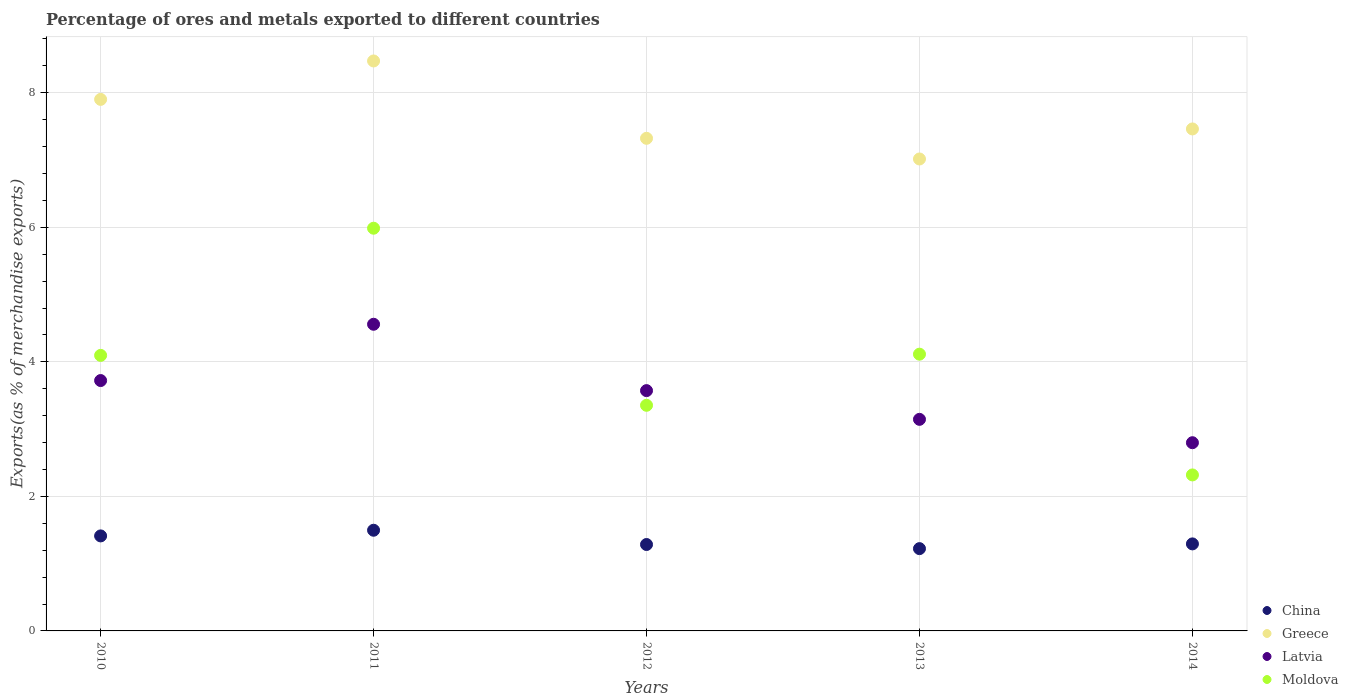Is the number of dotlines equal to the number of legend labels?
Offer a very short reply. Yes. What is the percentage of exports to different countries in Greece in 2014?
Offer a very short reply. 7.46. Across all years, what is the maximum percentage of exports to different countries in Greece?
Give a very brief answer. 8.47. Across all years, what is the minimum percentage of exports to different countries in Greece?
Provide a succinct answer. 7.02. In which year was the percentage of exports to different countries in Moldova maximum?
Offer a very short reply. 2011. In which year was the percentage of exports to different countries in Latvia minimum?
Give a very brief answer. 2014. What is the total percentage of exports to different countries in Greece in the graph?
Provide a succinct answer. 38.17. What is the difference between the percentage of exports to different countries in Latvia in 2012 and that in 2014?
Your answer should be very brief. 0.77. What is the difference between the percentage of exports to different countries in Greece in 2011 and the percentage of exports to different countries in Latvia in 2013?
Your answer should be very brief. 5.33. What is the average percentage of exports to different countries in Moldova per year?
Make the answer very short. 3.97. In the year 2014, what is the difference between the percentage of exports to different countries in Greece and percentage of exports to different countries in China?
Offer a very short reply. 6.17. In how many years, is the percentage of exports to different countries in Moldova greater than 3.6 %?
Provide a succinct answer. 3. What is the ratio of the percentage of exports to different countries in China in 2012 to that in 2013?
Keep it short and to the point. 1.05. Is the percentage of exports to different countries in Greece in 2010 less than that in 2013?
Provide a succinct answer. No. Is the difference between the percentage of exports to different countries in Greece in 2010 and 2013 greater than the difference between the percentage of exports to different countries in China in 2010 and 2013?
Keep it short and to the point. Yes. What is the difference between the highest and the second highest percentage of exports to different countries in China?
Provide a succinct answer. 0.08. What is the difference between the highest and the lowest percentage of exports to different countries in Greece?
Ensure brevity in your answer.  1.46. Is the sum of the percentage of exports to different countries in Greece in 2012 and 2014 greater than the maximum percentage of exports to different countries in Moldova across all years?
Offer a terse response. Yes. Is it the case that in every year, the sum of the percentage of exports to different countries in Greece and percentage of exports to different countries in Latvia  is greater than the sum of percentage of exports to different countries in China and percentage of exports to different countries in Moldova?
Offer a very short reply. Yes. Does the percentage of exports to different countries in Moldova monotonically increase over the years?
Provide a succinct answer. No. Does the graph contain any zero values?
Give a very brief answer. No. Does the graph contain grids?
Your response must be concise. Yes. How many legend labels are there?
Provide a succinct answer. 4. What is the title of the graph?
Your answer should be very brief. Percentage of ores and metals exported to different countries. Does "South Africa" appear as one of the legend labels in the graph?
Offer a terse response. No. What is the label or title of the Y-axis?
Give a very brief answer. Exports(as % of merchandise exports). What is the Exports(as % of merchandise exports) of China in 2010?
Ensure brevity in your answer.  1.41. What is the Exports(as % of merchandise exports) of Greece in 2010?
Your answer should be very brief. 7.9. What is the Exports(as % of merchandise exports) in Latvia in 2010?
Your answer should be very brief. 3.72. What is the Exports(as % of merchandise exports) of Moldova in 2010?
Give a very brief answer. 4.1. What is the Exports(as % of merchandise exports) of China in 2011?
Your answer should be compact. 1.5. What is the Exports(as % of merchandise exports) in Greece in 2011?
Make the answer very short. 8.47. What is the Exports(as % of merchandise exports) of Latvia in 2011?
Provide a short and direct response. 4.56. What is the Exports(as % of merchandise exports) of Moldova in 2011?
Offer a terse response. 5.99. What is the Exports(as % of merchandise exports) in China in 2012?
Provide a succinct answer. 1.28. What is the Exports(as % of merchandise exports) of Greece in 2012?
Your answer should be very brief. 7.32. What is the Exports(as % of merchandise exports) in Latvia in 2012?
Offer a very short reply. 3.57. What is the Exports(as % of merchandise exports) in Moldova in 2012?
Ensure brevity in your answer.  3.35. What is the Exports(as % of merchandise exports) of China in 2013?
Provide a succinct answer. 1.22. What is the Exports(as % of merchandise exports) of Greece in 2013?
Your answer should be compact. 7.02. What is the Exports(as % of merchandise exports) in Latvia in 2013?
Your answer should be compact. 3.14. What is the Exports(as % of merchandise exports) of Moldova in 2013?
Your answer should be compact. 4.11. What is the Exports(as % of merchandise exports) in China in 2014?
Provide a short and direct response. 1.29. What is the Exports(as % of merchandise exports) in Greece in 2014?
Provide a succinct answer. 7.46. What is the Exports(as % of merchandise exports) of Latvia in 2014?
Keep it short and to the point. 2.8. What is the Exports(as % of merchandise exports) of Moldova in 2014?
Your response must be concise. 2.32. Across all years, what is the maximum Exports(as % of merchandise exports) in China?
Your answer should be very brief. 1.5. Across all years, what is the maximum Exports(as % of merchandise exports) of Greece?
Your response must be concise. 8.47. Across all years, what is the maximum Exports(as % of merchandise exports) in Latvia?
Make the answer very short. 4.56. Across all years, what is the maximum Exports(as % of merchandise exports) in Moldova?
Give a very brief answer. 5.99. Across all years, what is the minimum Exports(as % of merchandise exports) in China?
Make the answer very short. 1.22. Across all years, what is the minimum Exports(as % of merchandise exports) in Greece?
Provide a succinct answer. 7.02. Across all years, what is the minimum Exports(as % of merchandise exports) in Latvia?
Your answer should be compact. 2.8. Across all years, what is the minimum Exports(as % of merchandise exports) of Moldova?
Offer a very short reply. 2.32. What is the total Exports(as % of merchandise exports) in China in the graph?
Keep it short and to the point. 6.71. What is the total Exports(as % of merchandise exports) in Greece in the graph?
Your response must be concise. 38.17. What is the total Exports(as % of merchandise exports) in Latvia in the graph?
Offer a terse response. 17.79. What is the total Exports(as % of merchandise exports) of Moldova in the graph?
Your answer should be compact. 19.87. What is the difference between the Exports(as % of merchandise exports) of China in 2010 and that in 2011?
Offer a very short reply. -0.08. What is the difference between the Exports(as % of merchandise exports) in Greece in 2010 and that in 2011?
Provide a succinct answer. -0.57. What is the difference between the Exports(as % of merchandise exports) of Latvia in 2010 and that in 2011?
Give a very brief answer. -0.84. What is the difference between the Exports(as % of merchandise exports) of Moldova in 2010 and that in 2011?
Your answer should be compact. -1.89. What is the difference between the Exports(as % of merchandise exports) in China in 2010 and that in 2012?
Keep it short and to the point. 0.13. What is the difference between the Exports(as % of merchandise exports) in Greece in 2010 and that in 2012?
Give a very brief answer. 0.58. What is the difference between the Exports(as % of merchandise exports) of Latvia in 2010 and that in 2012?
Give a very brief answer. 0.15. What is the difference between the Exports(as % of merchandise exports) of Moldova in 2010 and that in 2012?
Give a very brief answer. 0.74. What is the difference between the Exports(as % of merchandise exports) of China in 2010 and that in 2013?
Give a very brief answer. 0.19. What is the difference between the Exports(as % of merchandise exports) of Greece in 2010 and that in 2013?
Keep it short and to the point. 0.89. What is the difference between the Exports(as % of merchandise exports) of Latvia in 2010 and that in 2013?
Your answer should be very brief. 0.58. What is the difference between the Exports(as % of merchandise exports) of Moldova in 2010 and that in 2013?
Offer a terse response. -0.02. What is the difference between the Exports(as % of merchandise exports) in China in 2010 and that in 2014?
Provide a succinct answer. 0.12. What is the difference between the Exports(as % of merchandise exports) in Greece in 2010 and that in 2014?
Offer a very short reply. 0.44. What is the difference between the Exports(as % of merchandise exports) of Latvia in 2010 and that in 2014?
Your response must be concise. 0.92. What is the difference between the Exports(as % of merchandise exports) of Moldova in 2010 and that in 2014?
Provide a short and direct response. 1.78. What is the difference between the Exports(as % of merchandise exports) of China in 2011 and that in 2012?
Your response must be concise. 0.21. What is the difference between the Exports(as % of merchandise exports) in Greece in 2011 and that in 2012?
Make the answer very short. 1.15. What is the difference between the Exports(as % of merchandise exports) in Latvia in 2011 and that in 2012?
Give a very brief answer. 0.99. What is the difference between the Exports(as % of merchandise exports) of Moldova in 2011 and that in 2012?
Your response must be concise. 2.63. What is the difference between the Exports(as % of merchandise exports) in China in 2011 and that in 2013?
Provide a succinct answer. 0.27. What is the difference between the Exports(as % of merchandise exports) in Greece in 2011 and that in 2013?
Make the answer very short. 1.46. What is the difference between the Exports(as % of merchandise exports) of Latvia in 2011 and that in 2013?
Your answer should be compact. 1.41. What is the difference between the Exports(as % of merchandise exports) in Moldova in 2011 and that in 2013?
Give a very brief answer. 1.87. What is the difference between the Exports(as % of merchandise exports) of China in 2011 and that in 2014?
Make the answer very short. 0.2. What is the difference between the Exports(as % of merchandise exports) in Greece in 2011 and that in 2014?
Offer a terse response. 1.01. What is the difference between the Exports(as % of merchandise exports) in Latvia in 2011 and that in 2014?
Offer a very short reply. 1.76. What is the difference between the Exports(as % of merchandise exports) of Moldova in 2011 and that in 2014?
Your answer should be compact. 3.67. What is the difference between the Exports(as % of merchandise exports) in China in 2012 and that in 2013?
Your answer should be very brief. 0.06. What is the difference between the Exports(as % of merchandise exports) in Greece in 2012 and that in 2013?
Your answer should be compact. 0.31. What is the difference between the Exports(as % of merchandise exports) in Latvia in 2012 and that in 2013?
Your answer should be compact. 0.43. What is the difference between the Exports(as % of merchandise exports) in Moldova in 2012 and that in 2013?
Give a very brief answer. -0.76. What is the difference between the Exports(as % of merchandise exports) of China in 2012 and that in 2014?
Provide a succinct answer. -0.01. What is the difference between the Exports(as % of merchandise exports) in Greece in 2012 and that in 2014?
Give a very brief answer. -0.14. What is the difference between the Exports(as % of merchandise exports) of Latvia in 2012 and that in 2014?
Ensure brevity in your answer.  0.77. What is the difference between the Exports(as % of merchandise exports) of Moldova in 2012 and that in 2014?
Provide a succinct answer. 1.04. What is the difference between the Exports(as % of merchandise exports) of China in 2013 and that in 2014?
Keep it short and to the point. -0.07. What is the difference between the Exports(as % of merchandise exports) of Greece in 2013 and that in 2014?
Offer a very short reply. -0.45. What is the difference between the Exports(as % of merchandise exports) in Latvia in 2013 and that in 2014?
Your response must be concise. 0.35. What is the difference between the Exports(as % of merchandise exports) of Moldova in 2013 and that in 2014?
Your response must be concise. 1.79. What is the difference between the Exports(as % of merchandise exports) in China in 2010 and the Exports(as % of merchandise exports) in Greece in 2011?
Give a very brief answer. -7.06. What is the difference between the Exports(as % of merchandise exports) in China in 2010 and the Exports(as % of merchandise exports) in Latvia in 2011?
Ensure brevity in your answer.  -3.15. What is the difference between the Exports(as % of merchandise exports) of China in 2010 and the Exports(as % of merchandise exports) of Moldova in 2011?
Offer a very short reply. -4.57. What is the difference between the Exports(as % of merchandise exports) in Greece in 2010 and the Exports(as % of merchandise exports) in Latvia in 2011?
Offer a very short reply. 3.34. What is the difference between the Exports(as % of merchandise exports) in Greece in 2010 and the Exports(as % of merchandise exports) in Moldova in 2011?
Ensure brevity in your answer.  1.92. What is the difference between the Exports(as % of merchandise exports) of Latvia in 2010 and the Exports(as % of merchandise exports) of Moldova in 2011?
Provide a short and direct response. -2.26. What is the difference between the Exports(as % of merchandise exports) in China in 2010 and the Exports(as % of merchandise exports) in Greece in 2012?
Ensure brevity in your answer.  -5.91. What is the difference between the Exports(as % of merchandise exports) in China in 2010 and the Exports(as % of merchandise exports) in Latvia in 2012?
Your response must be concise. -2.16. What is the difference between the Exports(as % of merchandise exports) in China in 2010 and the Exports(as % of merchandise exports) in Moldova in 2012?
Provide a succinct answer. -1.94. What is the difference between the Exports(as % of merchandise exports) of Greece in 2010 and the Exports(as % of merchandise exports) of Latvia in 2012?
Make the answer very short. 4.33. What is the difference between the Exports(as % of merchandise exports) of Greece in 2010 and the Exports(as % of merchandise exports) of Moldova in 2012?
Your response must be concise. 4.55. What is the difference between the Exports(as % of merchandise exports) of Latvia in 2010 and the Exports(as % of merchandise exports) of Moldova in 2012?
Provide a succinct answer. 0.37. What is the difference between the Exports(as % of merchandise exports) of China in 2010 and the Exports(as % of merchandise exports) of Greece in 2013?
Offer a terse response. -5.6. What is the difference between the Exports(as % of merchandise exports) of China in 2010 and the Exports(as % of merchandise exports) of Latvia in 2013?
Provide a short and direct response. -1.73. What is the difference between the Exports(as % of merchandise exports) of China in 2010 and the Exports(as % of merchandise exports) of Moldova in 2013?
Provide a succinct answer. -2.7. What is the difference between the Exports(as % of merchandise exports) of Greece in 2010 and the Exports(as % of merchandise exports) of Latvia in 2013?
Your answer should be very brief. 4.76. What is the difference between the Exports(as % of merchandise exports) in Greece in 2010 and the Exports(as % of merchandise exports) in Moldova in 2013?
Provide a short and direct response. 3.79. What is the difference between the Exports(as % of merchandise exports) of Latvia in 2010 and the Exports(as % of merchandise exports) of Moldova in 2013?
Provide a succinct answer. -0.39. What is the difference between the Exports(as % of merchandise exports) of China in 2010 and the Exports(as % of merchandise exports) of Greece in 2014?
Provide a short and direct response. -6.05. What is the difference between the Exports(as % of merchandise exports) in China in 2010 and the Exports(as % of merchandise exports) in Latvia in 2014?
Give a very brief answer. -1.39. What is the difference between the Exports(as % of merchandise exports) in China in 2010 and the Exports(as % of merchandise exports) in Moldova in 2014?
Give a very brief answer. -0.91. What is the difference between the Exports(as % of merchandise exports) in Greece in 2010 and the Exports(as % of merchandise exports) in Latvia in 2014?
Make the answer very short. 5.1. What is the difference between the Exports(as % of merchandise exports) in Greece in 2010 and the Exports(as % of merchandise exports) in Moldova in 2014?
Give a very brief answer. 5.58. What is the difference between the Exports(as % of merchandise exports) in Latvia in 2010 and the Exports(as % of merchandise exports) in Moldova in 2014?
Provide a short and direct response. 1.4. What is the difference between the Exports(as % of merchandise exports) in China in 2011 and the Exports(as % of merchandise exports) in Greece in 2012?
Offer a terse response. -5.83. What is the difference between the Exports(as % of merchandise exports) in China in 2011 and the Exports(as % of merchandise exports) in Latvia in 2012?
Provide a succinct answer. -2.08. What is the difference between the Exports(as % of merchandise exports) of China in 2011 and the Exports(as % of merchandise exports) of Moldova in 2012?
Provide a short and direct response. -1.86. What is the difference between the Exports(as % of merchandise exports) of Greece in 2011 and the Exports(as % of merchandise exports) of Latvia in 2012?
Your answer should be compact. 4.9. What is the difference between the Exports(as % of merchandise exports) in Greece in 2011 and the Exports(as % of merchandise exports) in Moldova in 2012?
Keep it short and to the point. 5.12. What is the difference between the Exports(as % of merchandise exports) in Latvia in 2011 and the Exports(as % of merchandise exports) in Moldova in 2012?
Offer a very short reply. 1.2. What is the difference between the Exports(as % of merchandise exports) of China in 2011 and the Exports(as % of merchandise exports) of Greece in 2013?
Keep it short and to the point. -5.52. What is the difference between the Exports(as % of merchandise exports) of China in 2011 and the Exports(as % of merchandise exports) of Latvia in 2013?
Your response must be concise. -1.65. What is the difference between the Exports(as % of merchandise exports) in China in 2011 and the Exports(as % of merchandise exports) in Moldova in 2013?
Your response must be concise. -2.62. What is the difference between the Exports(as % of merchandise exports) in Greece in 2011 and the Exports(as % of merchandise exports) in Latvia in 2013?
Keep it short and to the point. 5.33. What is the difference between the Exports(as % of merchandise exports) of Greece in 2011 and the Exports(as % of merchandise exports) of Moldova in 2013?
Offer a terse response. 4.36. What is the difference between the Exports(as % of merchandise exports) of Latvia in 2011 and the Exports(as % of merchandise exports) of Moldova in 2013?
Provide a short and direct response. 0.44. What is the difference between the Exports(as % of merchandise exports) of China in 2011 and the Exports(as % of merchandise exports) of Greece in 2014?
Your answer should be compact. -5.97. What is the difference between the Exports(as % of merchandise exports) of China in 2011 and the Exports(as % of merchandise exports) of Latvia in 2014?
Your response must be concise. -1.3. What is the difference between the Exports(as % of merchandise exports) in China in 2011 and the Exports(as % of merchandise exports) in Moldova in 2014?
Provide a short and direct response. -0.82. What is the difference between the Exports(as % of merchandise exports) in Greece in 2011 and the Exports(as % of merchandise exports) in Latvia in 2014?
Your response must be concise. 5.67. What is the difference between the Exports(as % of merchandise exports) of Greece in 2011 and the Exports(as % of merchandise exports) of Moldova in 2014?
Offer a very short reply. 6.15. What is the difference between the Exports(as % of merchandise exports) in Latvia in 2011 and the Exports(as % of merchandise exports) in Moldova in 2014?
Make the answer very short. 2.24. What is the difference between the Exports(as % of merchandise exports) in China in 2012 and the Exports(as % of merchandise exports) in Greece in 2013?
Give a very brief answer. -5.73. What is the difference between the Exports(as % of merchandise exports) of China in 2012 and the Exports(as % of merchandise exports) of Latvia in 2013?
Give a very brief answer. -1.86. What is the difference between the Exports(as % of merchandise exports) of China in 2012 and the Exports(as % of merchandise exports) of Moldova in 2013?
Keep it short and to the point. -2.83. What is the difference between the Exports(as % of merchandise exports) of Greece in 2012 and the Exports(as % of merchandise exports) of Latvia in 2013?
Your answer should be compact. 4.18. What is the difference between the Exports(as % of merchandise exports) in Greece in 2012 and the Exports(as % of merchandise exports) in Moldova in 2013?
Keep it short and to the point. 3.21. What is the difference between the Exports(as % of merchandise exports) of Latvia in 2012 and the Exports(as % of merchandise exports) of Moldova in 2013?
Offer a very short reply. -0.54. What is the difference between the Exports(as % of merchandise exports) in China in 2012 and the Exports(as % of merchandise exports) in Greece in 2014?
Provide a short and direct response. -6.18. What is the difference between the Exports(as % of merchandise exports) in China in 2012 and the Exports(as % of merchandise exports) in Latvia in 2014?
Your response must be concise. -1.51. What is the difference between the Exports(as % of merchandise exports) in China in 2012 and the Exports(as % of merchandise exports) in Moldova in 2014?
Give a very brief answer. -1.03. What is the difference between the Exports(as % of merchandise exports) of Greece in 2012 and the Exports(as % of merchandise exports) of Latvia in 2014?
Provide a short and direct response. 4.52. What is the difference between the Exports(as % of merchandise exports) in Greece in 2012 and the Exports(as % of merchandise exports) in Moldova in 2014?
Provide a succinct answer. 5. What is the difference between the Exports(as % of merchandise exports) of Latvia in 2012 and the Exports(as % of merchandise exports) of Moldova in 2014?
Your answer should be very brief. 1.25. What is the difference between the Exports(as % of merchandise exports) in China in 2013 and the Exports(as % of merchandise exports) in Greece in 2014?
Your answer should be very brief. -6.24. What is the difference between the Exports(as % of merchandise exports) in China in 2013 and the Exports(as % of merchandise exports) in Latvia in 2014?
Make the answer very short. -1.57. What is the difference between the Exports(as % of merchandise exports) of China in 2013 and the Exports(as % of merchandise exports) of Moldova in 2014?
Give a very brief answer. -1.1. What is the difference between the Exports(as % of merchandise exports) of Greece in 2013 and the Exports(as % of merchandise exports) of Latvia in 2014?
Offer a very short reply. 4.22. What is the difference between the Exports(as % of merchandise exports) in Greece in 2013 and the Exports(as % of merchandise exports) in Moldova in 2014?
Provide a short and direct response. 4.7. What is the difference between the Exports(as % of merchandise exports) in Latvia in 2013 and the Exports(as % of merchandise exports) in Moldova in 2014?
Provide a short and direct response. 0.83. What is the average Exports(as % of merchandise exports) in China per year?
Provide a succinct answer. 1.34. What is the average Exports(as % of merchandise exports) of Greece per year?
Provide a short and direct response. 7.63. What is the average Exports(as % of merchandise exports) of Latvia per year?
Provide a short and direct response. 3.56. What is the average Exports(as % of merchandise exports) in Moldova per year?
Your answer should be compact. 3.97. In the year 2010, what is the difference between the Exports(as % of merchandise exports) of China and Exports(as % of merchandise exports) of Greece?
Your answer should be very brief. -6.49. In the year 2010, what is the difference between the Exports(as % of merchandise exports) of China and Exports(as % of merchandise exports) of Latvia?
Your answer should be compact. -2.31. In the year 2010, what is the difference between the Exports(as % of merchandise exports) of China and Exports(as % of merchandise exports) of Moldova?
Your response must be concise. -2.68. In the year 2010, what is the difference between the Exports(as % of merchandise exports) in Greece and Exports(as % of merchandise exports) in Latvia?
Provide a short and direct response. 4.18. In the year 2010, what is the difference between the Exports(as % of merchandise exports) in Greece and Exports(as % of merchandise exports) in Moldova?
Offer a terse response. 3.81. In the year 2010, what is the difference between the Exports(as % of merchandise exports) in Latvia and Exports(as % of merchandise exports) in Moldova?
Provide a succinct answer. -0.37. In the year 2011, what is the difference between the Exports(as % of merchandise exports) in China and Exports(as % of merchandise exports) in Greece?
Provide a short and direct response. -6.98. In the year 2011, what is the difference between the Exports(as % of merchandise exports) in China and Exports(as % of merchandise exports) in Latvia?
Provide a short and direct response. -3.06. In the year 2011, what is the difference between the Exports(as % of merchandise exports) of China and Exports(as % of merchandise exports) of Moldova?
Provide a short and direct response. -4.49. In the year 2011, what is the difference between the Exports(as % of merchandise exports) in Greece and Exports(as % of merchandise exports) in Latvia?
Ensure brevity in your answer.  3.91. In the year 2011, what is the difference between the Exports(as % of merchandise exports) in Greece and Exports(as % of merchandise exports) in Moldova?
Give a very brief answer. 2.49. In the year 2011, what is the difference between the Exports(as % of merchandise exports) of Latvia and Exports(as % of merchandise exports) of Moldova?
Provide a succinct answer. -1.43. In the year 2012, what is the difference between the Exports(as % of merchandise exports) of China and Exports(as % of merchandise exports) of Greece?
Offer a terse response. -6.04. In the year 2012, what is the difference between the Exports(as % of merchandise exports) of China and Exports(as % of merchandise exports) of Latvia?
Your answer should be compact. -2.29. In the year 2012, what is the difference between the Exports(as % of merchandise exports) of China and Exports(as % of merchandise exports) of Moldova?
Give a very brief answer. -2.07. In the year 2012, what is the difference between the Exports(as % of merchandise exports) of Greece and Exports(as % of merchandise exports) of Latvia?
Provide a short and direct response. 3.75. In the year 2012, what is the difference between the Exports(as % of merchandise exports) in Greece and Exports(as % of merchandise exports) in Moldova?
Your answer should be compact. 3.97. In the year 2012, what is the difference between the Exports(as % of merchandise exports) in Latvia and Exports(as % of merchandise exports) in Moldova?
Make the answer very short. 0.22. In the year 2013, what is the difference between the Exports(as % of merchandise exports) in China and Exports(as % of merchandise exports) in Greece?
Ensure brevity in your answer.  -5.79. In the year 2013, what is the difference between the Exports(as % of merchandise exports) of China and Exports(as % of merchandise exports) of Latvia?
Keep it short and to the point. -1.92. In the year 2013, what is the difference between the Exports(as % of merchandise exports) in China and Exports(as % of merchandise exports) in Moldova?
Your answer should be very brief. -2.89. In the year 2013, what is the difference between the Exports(as % of merchandise exports) of Greece and Exports(as % of merchandise exports) of Latvia?
Offer a very short reply. 3.87. In the year 2013, what is the difference between the Exports(as % of merchandise exports) in Greece and Exports(as % of merchandise exports) in Moldova?
Ensure brevity in your answer.  2.9. In the year 2013, what is the difference between the Exports(as % of merchandise exports) in Latvia and Exports(as % of merchandise exports) in Moldova?
Your answer should be very brief. -0.97. In the year 2014, what is the difference between the Exports(as % of merchandise exports) of China and Exports(as % of merchandise exports) of Greece?
Make the answer very short. -6.17. In the year 2014, what is the difference between the Exports(as % of merchandise exports) in China and Exports(as % of merchandise exports) in Latvia?
Ensure brevity in your answer.  -1.5. In the year 2014, what is the difference between the Exports(as % of merchandise exports) in China and Exports(as % of merchandise exports) in Moldova?
Your answer should be very brief. -1.03. In the year 2014, what is the difference between the Exports(as % of merchandise exports) of Greece and Exports(as % of merchandise exports) of Latvia?
Give a very brief answer. 4.66. In the year 2014, what is the difference between the Exports(as % of merchandise exports) of Greece and Exports(as % of merchandise exports) of Moldova?
Provide a short and direct response. 5.14. In the year 2014, what is the difference between the Exports(as % of merchandise exports) of Latvia and Exports(as % of merchandise exports) of Moldova?
Offer a very short reply. 0.48. What is the ratio of the Exports(as % of merchandise exports) of China in 2010 to that in 2011?
Your answer should be compact. 0.94. What is the ratio of the Exports(as % of merchandise exports) of Greece in 2010 to that in 2011?
Your answer should be compact. 0.93. What is the ratio of the Exports(as % of merchandise exports) of Latvia in 2010 to that in 2011?
Keep it short and to the point. 0.82. What is the ratio of the Exports(as % of merchandise exports) of Moldova in 2010 to that in 2011?
Give a very brief answer. 0.68. What is the ratio of the Exports(as % of merchandise exports) of China in 2010 to that in 2012?
Provide a succinct answer. 1.1. What is the ratio of the Exports(as % of merchandise exports) in Greece in 2010 to that in 2012?
Offer a terse response. 1.08. What is the ratio of the Exports(as % of merchandise exports) of Latvia in 2010 to that in 2012?
Your answer should be compact. 1.04. What is the ratio of the Exports(as % of merchandise exports) of Moldova in 2010 to that in 2012?
Your answer should be compact. 1.22. What is the ratio of the Exports(as % of merchandise exports) of China in 2010 to that in 2013?
Your answer should be compact. 1.15. What is the ratio of the Exports(as % of merchandise exports) of Greece in 2010 to that in 2013?
Make the answer very short. 1.13. What is the ratio of the Exports(as % of merchandise exports) in Latvia in 2010 to that in 2013?
Give a very brief answer. 1.18. What is the ratio of the Exports(as % of merchandise exports) of Moldova in 2010 to that in 2013?
Provide a short and direct response. 1. What is the ratio of the Exports(as % of merchandise exports) of China in 2010 to that in 2014?
Give a very brief answer. 1.09. What is the ratio of the Exports(as % of merchandise exports) of Greece in 2010 to that in 2014?
Ensure brevity in your answer.  1.06. What is the ratio of the Exports(as % of merchandise exports) in Latvia in 2010 to that in 2014?
Provide a short and direct response. 1.33. What is the ratio of the Exports(as % of merchandise exports) of Moldova in 2010 to that in 2014?
Provide a succinct answer. 1.77. What is the ratio of the Exports(as % of merchandise exports) of China in 2011 to that in 2012?
Make the answer very short. 1.17. What is the ratio of the Exports(as % of merchandise exports) of Greece in 2011 to that in 2012?
Offer a very short reply. 1.16. What is the ratio of the Exports(as % of merchandise exports) of Latvia in 2011 to that in 2012?
Provide a short and direct response. 1.28. What is the ratio of the Exports(as % of merchandise exports) of Moldova in 2011 to that in 2012?
Your response must be concise. 1.78. What is the ratio of the Exports(as % of merchandise exports) of China in 2011 to that in 2013?
Offer a terse response. 1.22. What is the ratio of the Exports(as % of merchandise exports) of Greece in 2011 to that in 2013?
Provide a succinct answer. 1.21. What is the ratio of the Exports(as % of merchandise exports) in Latvia in 2011 to that in 2013?
Your response must be concise. 1.45. What is the ratio of the Exports(as % of merchandise exports) in Moldova in 2011 to that in 2013?
Your answer should be compact. 1.46. What is the ratio of the Exports(as % of merchandise exports) of China in 2011 to that in 2014?
Give a very brief answer. 1.16. What is the ratio of the Exports(as % of merchandise exports) in Greece in 2011 to that in 2014?
Ensure brevity in your answer.  1.14. What is the ratio of the Exports(as % of merchandise exports) of Latvia in 2011 to that in 2014?
Provide a succinct answer. 1.63. What is the ratio of the Exports(as % of merchandise exports) of Moldova in 2011 to that in 2014?
Your answer should be very brief. 2.58. What is the ratio of the Exports(as % of merchandise exports) in China in 2012 to that in 2013?
Your answer should be compact. 1.05. What is the ratio of the Exports(as % of merchandise exports) of Greece in 2012 to that in 2013?
Keep it short and to the point. 1.04. What is the ratio of the Exports(as % of merchandise exports) of Latvia in 2012 to that in 2013?
Keep it short and to the point. 1.14. What is the ratio of the Exports(as % of merchandise exports) in Moldova in 2012 to that in 2013?
Your response must be concise. 0.82. What is the ratio of the Exports(as % of merchandise exports) in Greece in 2012 to that in 2014?
Keep it short and to the point. 0.98. What is the ratio of the Exports(as % of merchandise exports) of Latvia in 2012 to that in 2014?
Offer a terse response. 1.28. What is the ratio of the Exports(as % of merchandise exports) of Moldova in 2012 to that in 2014?
Provide a short and direct response. 1.45. What is the ratio of the Exports(as % of merchandise exports) of China in 2013 to that in 2014?
Offer a terse response. 0.95. What is the ratio of the Exports(as % of merchandise exports) of Greece in 2013 to that in 2014?
Offer a terse response. 0.94. What is the ratio of the Exports(as % of merchandise exports) of Latvia in 2013 to that in 2014?
Ensure brevity in your answer.  1.12. What is the ratio of the Exports(as % of merchandise exports) of Moldova in 2013 to that in 2014?
Provide a short and direct response. 1.77. What is the difference between the highest and the second highest Exports(as % of merchandise exports) of China?
Your response must be concise. 0.08. What is the difference between the highest and the second highest Exports(as % of merchandise exports) of Greece?
Your response must be concise. 0.57. What is the difference between the highest and the second highest Exports(as % of merchandise exports) in Latvia?
Your response must be concise. 0.84. What is the difference between the highest and the second highest Exports(as % of merchandise exports) in Moldova?
Offer a very short reply. 1.87. What is the difference between the highest and the lowest Exports(as % of merchandise exports) in China?
Your answer should be compact. 0.27. What is the difference between the highest and the lowest Exports(as % of merchandise exports) in Greece?
Offer a terse response. 1.46. What is the difference between the highest and the lowest Exports(as % of merchandise exports) of Latvia?
Provide a succinct answer. 1.76. What is the difference between the highest and the lowest Exports(as % of merchandise exports) in Moldova?
Your response must be concise. 3.67. 